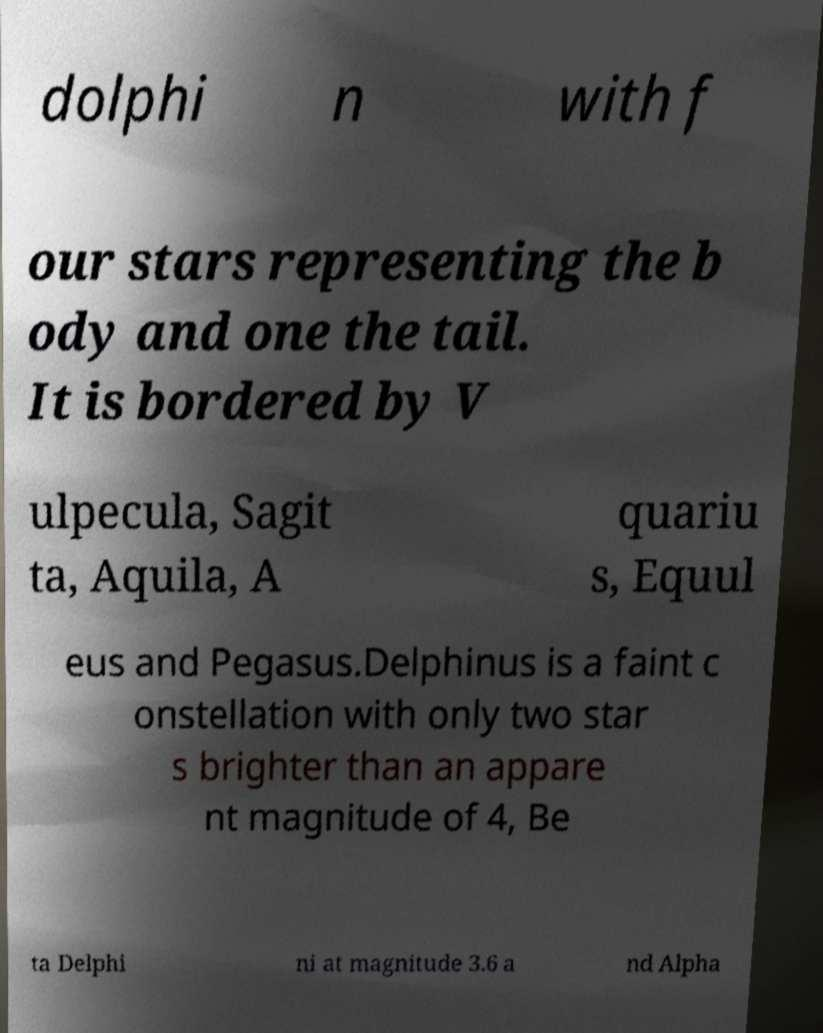Please read and relay the text visible in this image. What does it say? dolphi n with f our stars representing the b ody and one the tail. It is bordered by V ulpecula, Sagit ta, Aquila, A quariu s, Equul eus and Pegasus.Delphinus is a faint c onstellation with only two star s brighter than an appare nt magnitude of 4, Be ta Delphi ni at magnitude 3.6 a nd Alpha 